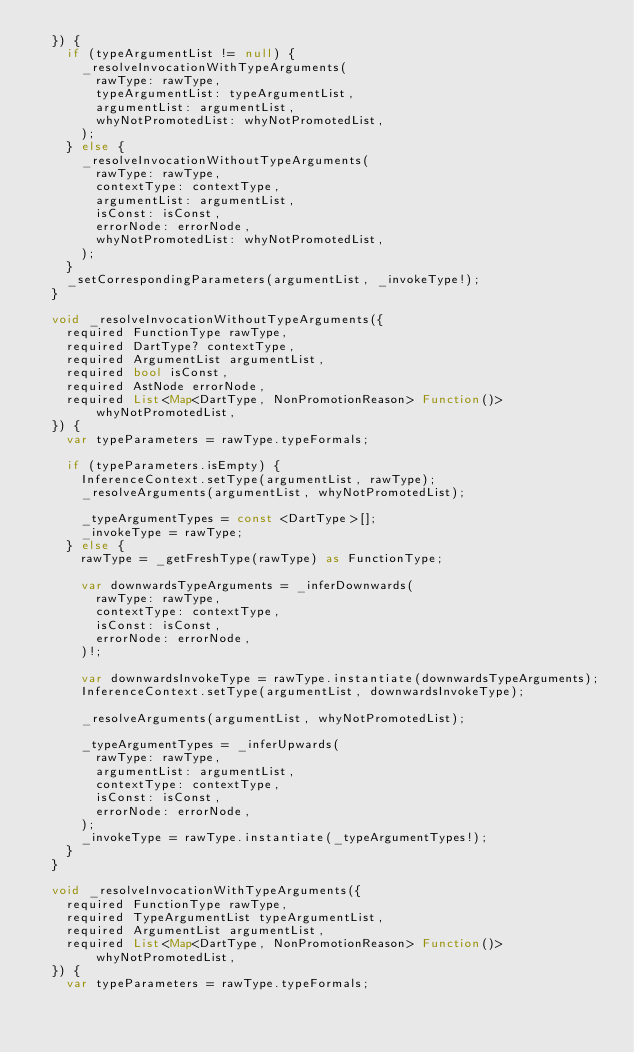Convert code to text. <code><loc_0><loc_0><loc_500><loc_500><_Dart_>  }) {
    if (typeArgumentList != null) {
      _resolveInvocationWithTypeArguments(
        rawType: rawType,
        typeArgumentList: typeArgumentList,
        argumentList: argumentList,
        whyNotPromotedList: whyNotPromotedList,
      );
    } else {
      _resolveInvocationWithoutTypeArguments(
        rawType: rawType,
        contextType: contextType,
        argumentList: argumentList,
        isConst: isConst,
        errorNode: errorNode,
        whyNotPromotedList: whyNotPromotedList,
      );
    }
    _setCorrespondingParameters(argumentList, _invokeType!);
  }

  void _resolveInvocationWithoutTypeArguments({
    required FunctionType rawType,
    required DartType? contextType,
    required ArgumentList argumentList,
    required bool isConst,
    required AstNode errorNode,
    required List<Map<DartType, NonPromotionReason> Function()>
        whyNotPromotedList,
  }) {
    var typeParameters = rawType.typeFormals;

    if (typeParameters.isEmpty) {
      InferenceContext.setType(argumentList, rawType);
      _resolveArguments(argumentList, whyNotPromotedList);

      _typeArgumentTypes = const <DartType>[];
      _invokeType = rawType;
    } else {
      rawType = _getFreshType(rawType) as FunctionType;

      var downwardsTypeArguments = _inferDownwards(
        rawType: rawType,
        contextType: contextType,
        isConst: isConst,
        errorNode: errorNode,
      )!;

      var downwardsInvokeType = rawType.instantiate(downwardsTypeArguments);
      InferenceContext.setType(argumentList, downwardsInvokeType);

      _resolveArguments(argumentList, whyNotPromotedList);

      _typeArgumentTypes = _inferUpwards(
        rawType: rawType,
        argumentList: argumentList,
        contextType: contextType,
        isConst: isConst,
        errorNode: errorNode,
      );
      _invokeType = rawType.instantiate(_typeArgumentTypes!);
    }
  }

  void _resolveInvocationWithTypeArguments({
    required FunctionType rawType,
    required TypeArgumentList typeArgumentList,
    required ArgumentList argumentList,
    required List<Map<DartType, NonPromotionReason> Function()>
        whyNotPromotedList,
  }) {
    var typeParameters = rawType.typeFormals;
</code> 